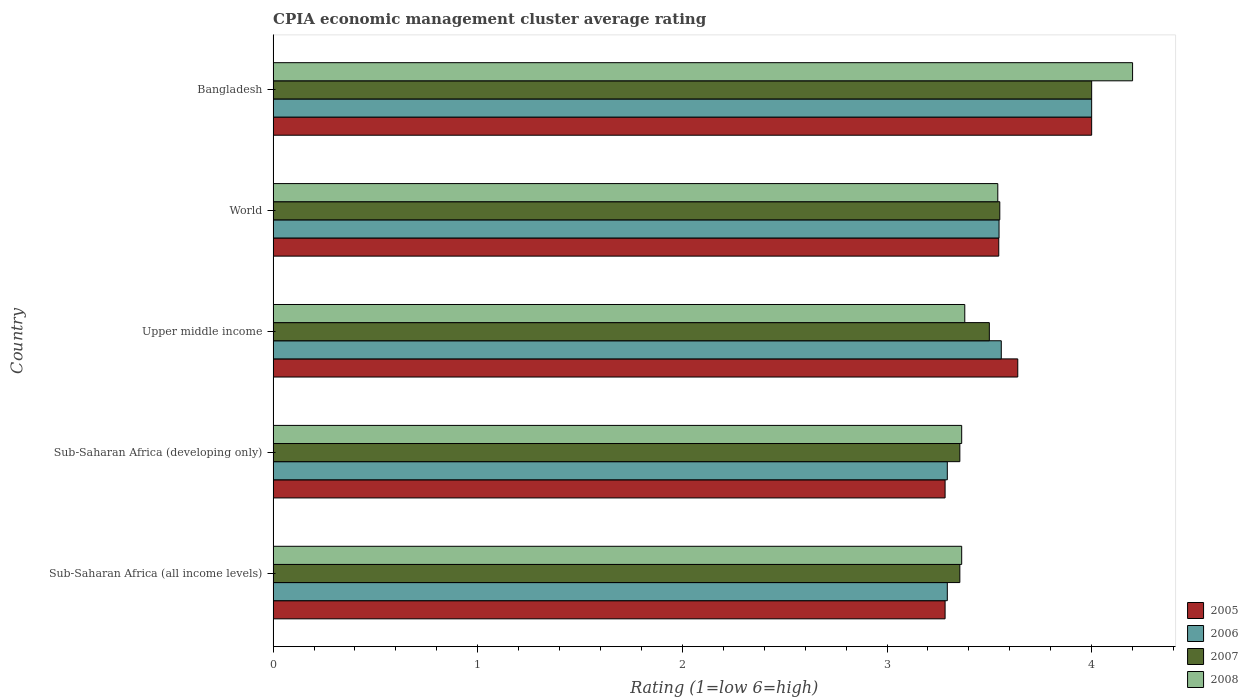How many different coloured bars are there?
Make the answer very short. 4. How many groups of bars are there?
Ensure brevity in your answer.  5. Are the number of bars per tick equal to the number of legend labels?
Your answer should be compact. Yes. Are the number of bars on each tick of the Y-axis equal?
Give a very brief answer. Yes. How many bars are there on the 5th tick from the bottom?
Give a very brief answer. 4. What is the label of the 3rd group of bars from the top?
Ensure brevity in your answer.  Upper middle income. What is the CPIA rating in 2008 in Sub-Saharan Africa (developing only)?
Make the answer very short. 3.36. Across all countries, what is the maximum CPIA rating in 2005?
Provide a short and direct response. 4. Across all countries, what is the minimum CPIA rating in 2008?
Offer a terse response. 3.36. In which country was the CPIA rating in 2006 minimum?
Provide a short and direct response. Sub-Saharan Africa (all income levels). What is the total CPIA rating in 2006 in the graph?
Give a very brief answer. 17.69. What is the difference between the CPIA rating in 2008 in Bangladesh and that in Sub-Saharan Africa (developing only)?
Make the answer very short. 0.84. What is the difference between the CPIA rating in 2008 in Sub-Saharan Africa (all income levels) and the CPIA rating in 2005 in World?
Ensure brevity in your answer.  -0.18. What is the average CPIA rating in 2007 per country?
Your answer should be very brief. 3.55. What is the difference between the CPIA rating in 2006 and CPIA rating in 2005 in Sub-Saharan Africa (all income levels)?
Your answer should be very brief. 0.01. What is the ratio of the CPIA rating in 2005 in Bangladesh to that in World?
Your answer should be compact. 1.13. Is the CPIA rating in 2006 in Sub-Saharan Africa (all income levels) less than that in Upper middle income?
Your answer should be compact. Yes. What is the difference between the highest and the second highest CPIA rating in 2007?
Provide a succinct answer. 0.45. What is the difference between the highest and the lowest CPIA rating in 2007?
Provide a short and direct response. 0.64. In how many countries, is the CPIA rating in 2007 greater than the average CPIA rating in 2007 taken over all countries?
Make the answer very short. 1. Is the sum of the CPIA rating in 2006 in Bangladesh and Sub-Saharan Africa (all income levels) greater than the maximum CPIA rating in 2007 across all countries?
Make the answer very short. Yes. Is it the case that in every country, the sum of the CPIA rating in 2008 and CPIA rating in 2007 is greater than the sum of CPIA rating in 2006 and CPIA rating in 2005?
Offer a very short reply. No. How many bars are there?
Ensure brevity in your answer.  20. What is the difference between two consecutive major ticks on the X-axis?
Ensure brevity in your answer.  1. Does the graph contain any zero values?
Give a very brief answer. No. Does the graph contain grids?
Your answer should be very brief. No. Where does the legend appear in the graph?
Keep it short and to the point. Bottom right. What is the title of the graph?
Offer a very short reply. CPIA economic management cluster average rating. What is the label or title of the X-axis?
Your answer should be very brief. Rating (1=low 6=high). What is the label or title of the Y-axis?
Keep it short and to the point. Country. What is the Rating (1=low 6=high) in 2005 in Sub-Saharan Africa (all income levels)?
Your response must be concise. 3.28. What is the Rating (1=low 6=high) of 2006 in Sub-Saharan Africa (all income levels)?
Make the answer very short. 3.29. What is the Rating (1=low 6=high) of 2007 in Sub-Saharan Africa (all income levels)?
Your answer should be compact. 3.36. What is the Rating (1=low 6=high) in 2008 in Sub-Saharan Africa (all income levels)?
Offer a very short reply. 3.36. What is the Rating (1=low 6=high) in 2005 in Sub-Saharan Africa (developing only)?
Your answer should be compact. 3.28. What is the Rating (1=low 6=high) in 2006 in Sub-Saharan Africa (developing only)?
Keep it short and to the point. 3.29. What is the Rating (1=low 6=high) in 2007 in Sub-Saharan Africa (developing only)?
Your answer should be very brief. 3.36. What is the Rating (1=low 6=high) of 2008 in Sub-Saharan Africa (developing only)?
Provide a short and direct response. 3.36. What is the Rating (1=low 6=high) of 2005 in Upper middle income?
Offer a very short reply. 3.64. What is the Rating (1=low 6=high) of 2006 in Upper middle income?
Provide a succinct answer. 3.56. What is the Rating (1=low 6=high) of 2008 in Upper middle income?
Offer a terse response. 3.38. What is the Rating (1=low 6=high) of 2005 in World?
Give a very brief answer. 3.55. What is the Rating (1=low 6=high) of 2006 in World?
Offer a very short reply. 3.55. What is the Rating (1=low 6=high) of 2007 in World?
Your response must be concise. 3.55. What is the Rating (1=low 6=high) of 2008 in World?
Keep it short and to the point. 3.54. What is the Rating (1=low 6=high) of 2005 in Bangladesh?
Your response must be concise. 4. What is the Rating (1=low 6=high) in 2007 in Bangladesh?
Offer a terse response. 4. What is the Rating (1=low 6=high) of 2008 in Bangladesh?
Provide a succinct answer. 4.2. Across all countries, what is the maximum Rating (1=low 6=high) of 2006?
Offer a terse response. 4. Across all countries, what is the maximum Rating (1=low 6=high) in 2008?
Ensure brevity in your answer.  4.2. Across all countries, what is the minimum Rating (1=low 6=high) of 2005?
Give a very brief answer. 3.28. Across all countries, what is the minimum Rating (1=low 6=high) in 2006?
Your response must be concise. 3.29. Across all countries, what is the minimum Rating (1=low 6=high) in 2007?
Make the answer very short. 3.36. Across all countries, what is the minimum Rating (1=low 6=high) of 2008?
Your answer should be very brief. 3.36. What is the total Rating (1=low 6=high) of 2005 in the graph?
Keep it short and to the point. 17.75. What is the total Rating (1=low 6=high) in 2006 in the graph?
Ensure brevity in your answer.  17.7. What is the total Rating (1=low 6=high) in 2007 in the graph?
Provide a succinct answer. 17.76. What is the total Rating (1=low 6=high) of 2008 in the graph?
Ensure brevity in your answer.  17.85. What is the difference between the Rating (1=low 6=high) in 2006 in Sub-Saharan Africa (all income levels) and that in Sub-Saharan Africa (developing only)?
Offer a terse response. 0. What is the difference between the Rating (1=low 6=high) of 2005 in Sub-Saharan Africa (all income levels) and that in Upper middle income?
Offer a terse response. -0.36. What is the difference between the Rating (1=low 6=high) in 2006 in Sub-Saharan Africa (all income levels) and that in Upper middle income?
Offer a terse response. -0.26. What is the difference between the Rating (1=low 6=high) in 2007 in Sub-Saharan Africa (all income levels) and that in Upper middle income?
Make the answer very short. -0.14. What is the difference between the Rating (1=low 6=high) in 2008 in Sub-Saharan Africa (all income levels) and that in Upper middle income?
Offer a terse response. -0.02. What is the difference between the Rating (1=low 6=high) of 2005 in Sub-Saharan Africa (all income levels) and that in World?
Offer a very short reply. -0.26. What is the difference between the Rating (1=low 6=high) of 2006 in Sub-Saharan Africa (all income levels) and that in World?
Your answer should be compact. -0.25. What is the difference between the Rating (1=low 6=high) in 2007 in Sub-Saharan Africa (all income levels) and that in World?
Your answer should be compact. -0.2. What is the difference between the Rating (1=low 6=high) of 2008 in Sub-Saharan Africa (all income levels) and that in World?
Your answer should be compact. -0.18. What is the difference between the Rating (1=low 6=high) of 2005 in Sub-Saharan Africa (all income levels) and that in Bangladesh?
Your answer should be compact. -0.72. What is the difference between the Rating (1=low 6=high) of 2006 in Sub-Saharan Africa (all income levels) and that in Bangladesh?
Keep it short and to the point. -0.71. What is the difference between the Rating (1=low 6=high) in 2007 in Sub-Saharan Africa (all income levels) and that in Bangladesh?
Ensure brevity in your answer.  -0.64. What is the difference between the Rating (1=low 6=high) of 2008 in Sub-Saharan Africa (all income levels) and that in Bangladesh?
Your answer should be compact. -0.84. What is the difference between the Rating (1=low 6=high) in 2005 in Sub-Saharan Africa (developing only) and that in Upper middle income?
Ensure brevity in your answer.  -0.36. What is the difference between the Rating (1=low 6=high) of 2006 in Sub-Saharan Africa (developing only) and that in Upper middle income?
Provide a short and direct response. -0.26. What is the difference between the Rating (1=low 6=high) of 2007 in Sub-Saharan Africa (developing only) and that in Upper middle income?
Give a very brief answer. -0.14. What is the difference between the Rating (1=low 6=high) in 2008 in Sub-Saharan Africa (developing only) and that in Upper middle income?
Ensure brevity in your answer.  -0.02. What is the difference between the Rating (1=low 6=high) in 2005 in Sub-Saharan Africa (developing only) and that in World?
Keep it short and to the point. -0.26. What is the difference between the Rating (1=low 6=high) of 2006 in Sub-Saharan Africa (developing only) and that in World?
Ensure brevity in your answer.  -0.25. What is the difference between the Rating (1=low 6=high) in 2007 in Sub-Saharan Africa (developing only) and that in World?
Your answer should be very brief. -0.2. What is the difference between the Rating (1=low 6=high) in 2008 in Sub-Saharan Africa (developing only) and that in World?
Offer a terse response. -0.18. What is the difference between the Rating (1=low 6=high) of 2005 in Sub-Saharan Africa (developing only) and that in Bangladesh?
Give a very brief answer. -0.72. What is the difference between the Rating (1=low 6=high) in 2006 in Sub-Saharan Africa (developing only) and that in Bangladesh?
Your answer should be very brief. -0.71. What is the difference between the Rating (1=low 6=high) in 2007 in Sub-Saharan Africa (developing only) and that in Bangladesh?
Ensure brevity in your answer.  -0.64. What is the difference between the Rating (1=low 6=high) of 2008 in Sub-Saharan Africa (developing only) and that in Bangladesh?
Give a very brief answer. -0.84. What is the difference between the Rating (1=low 6=high) of 2005 in Upper middle income and that in World?
Provide a succinct answer. 0.09. What is the difference between the Rating (1=low 6=high) of 2006 in Upper middle income and that in World?
Provide a succinct answer. 0.01. What is the difference between the Rating (1=low 6=high) in 2007 in Upper middle income and that in World?
Provide a succinct answer. -0.05. What is the difference between the Rating (1=low 6=high) in 2008 in Upper middle income and that in World?
Your response must be concise. -0.16. What is the difference between the Rating (1=low 6=high) of 2005 in Upper middle income and that in Bangladesh?
Provide a short and direct response. -0.36. What is the difference between the Rating (1=low 6=high) in 2006 in Upper middle income and that in Bangladesh?
Provide a short and direct response. -0.44. What is the difference between the Rating (1=low 6=high) of 2007 in Upper middle income and that in Bangladesh?
Offer a terse response. -0.5. What is the difference between the Rating (1=low 6=high) in 2008 in Upper middle income and that in Bangladesh?
Keep it short and to the point. -0.82. What is the difference between the Rating (1=low 6=high) of 2005 in World and that in Bangladesh?
Your response must be concise. -0.45. What is the difference between the Rating (1=low 6=high) in 2006 in World and that in Bangladesh?
Your response must be concise. -0.45. What is the difference between the Rating (1=low 6=high) of 2007 in World and that in Bangladesh?
Provide a short and direct response. -0.45. What is the difference between the Rating (1=low 6=high) in 2008 in World and that in Bangladesh?
Make the answer very short. -0.66. What is the difference between the Rating (1=low 6=high) in 2005 in Sub-Saharan Africa (all income levels) and the Rating (1=low 6=high) in 2006 in Sub-Saharan Africa (developing only)?
Give a very brief answer. -0.01. What is the difference between the Rating (1=low 6=high) of 2005 in Sub-Saharan Africa (all income levels) and the Rating (1=low 6=high) of 2007 in Sub-Saharan Africa (developing only)?
Provide a short and direct response. -0.07. What is the difference between the Rating (1=low 6=high) in 2005 in Sub-Saharan Africa (all income levels) and the Rating (1=low 6=high) in 2008 in Sub-Saharan Africa (developing only)?
Your response must be concise. -0.08. What is the difference between the Rating (1=low 6=high) of 2006 in Sub-Saharan Africa (all income levels) and the Rating (1=low 6=high) of 2007 in Sub-Saharan Africa (developing only)?
Make the answer very short. -0.06. What is the difference between the Rating (1=low 6=high) of 2006 in Sub-Saharan Africa (all income levels) and the Rating (1=low 6=high) of 2008 in Sub-Saharan Africa (developing only)?
Make the answer very short. -0.07. What is the difference between the Rating (1=low 6=high) of 2007 in Sub-Saharan Africa (all income levels) and the Rating (1=low 6=high) of 2008 in Sub-Saharan Africa (developing only)?
Your answer should be very brief. -0.01. What is the difference between the Rating (1=low 6=high) of 2005 in Sub-Saharan Africa (all income levels) and the Rating (1=low 6=high) of 2006 in Upper middle income?
Offer a very short reply. -0.27. What is the difference between the Rating (1=low 6=high) in 2005 in Sub-Saharan Africa (all income levels) and the Rating (1=low 6=high) in 2007 in Upper middle income?
Provide a short and direct response. -0.22. What is the difference between the Rating (1=low 6=high) of 2005 in Sub-Saharan Africa (all income levels) and the Rating (1=low 6=high) of 2008 in Upper middle income?
Offer a terse response. -0.1. What is the difference between the Rating (1=low 6=high) of 2006 in Sub-Saharan Africa (all income levels) and the Rating (1=low 6=high) of 2007 in Upper middle income?
Your answer should be compact. -0.21. What is the difference between the Rating (1=low 6=high) of 2006 in Sub-Saharan Africa (all income levels) and the Rating (1=low 6=high) of 2008 in Upper middle income?
Your response must be concise. -0.09. What is the difference between the Rating (1=low 6=high) in 2007 in Sub-Saharan Africa (all income levels) and the Rating (1=low 6=high) in 2008 in Upper middle income?
Provide a short and direct response. -0.02. What is the difference between the Rating (1=low 6=high) in 2005 in Sub-Saharan Africa (all income levels) and the Rating (1=low 6=high) in 2006 in World?
Ensure brevity in your answer.  -0.26. What is the difference between the Rating (1=low 6=high) of 2005 in Sub-Saharan Africa (all income levels) and the Rating (1=low 6=high) of 2007 in World?
Your answer should be very brief. -0.27. What is the difference between the Rating (1=low 6=high) of 2005 in Sub-Saharan Africa (all income levels) and the Rating (1=low 6=high) of 2008 in World?
Keep it short and to the point. -0.26. What is the difference between the Rating (1=low 6=high) of 2006 in Sub-Saharan Africa (all income levels) and the Rating (1=low 6=high) of 2007 in World?
Provide a short and direct response. -0.26. What is the difference between the Rating (1=low 6=high) of 2006 in Sub-Saharan Africa (all income levels) and the Rating (1=low 6=high) of 2008 in World?
Your answer should be very brief. -0.25. What is the difference between the Rating (1=low 6=high) in 2007 in Sub-Saharan Africa (all income levels) and the Rating (1=low 6=high) in 2008 in World?
Offer a very short reply. -0.19. What is the difference between the Rating (1=low 6=high) of 2005 in Sub-Saharan Africa (all income levels) and the Rating (1=low 6=high) of 2006 in Bangladesh?
Give a very brief answer. -0.72. What is the difference between the Rating (1=low 6=high) of 2005 in Sub-Saharan Africa (all income levels) and the Rating (1=low 6=high) of 2007 in Bangladesh?
Ensure brevity in your answer.  -0.72. What is the difference between the Rating (1=low 6=high) of 2005 in Sub-Saharan Africa (all income levels) and the Rating (1=low 6=high) of 2008 in Bangladesh?
Provide a short and direct response. -0.92. What is the difference between the Rating (1=low 6=high) in 2006 in Sub-Saharan Africa (all income levels) and the Rating (1=low 6=high) in 2007 in Bangladesh?
Provide a short and direct response. -0.71. What is the difference between the Rating (1=low 6=high) in 2006 in Sub-Saharan Africa (all income levels) and the Rating (1=low 6=high) in 2008 in Bangladesh?
Keep it short and to the point. -0.91. What is the difference between the Rating (1=low 6=high) of 2007 in Sub-Saharan Africa (all income levels) and the Rating (1=low 6=high) of 2008 in Bangladesh?
Your answer should be compact. -0.84. What is the difference between the Rating (1=low 6=high) of 2005 in Sub-Saharan Africa (developing only) and the Rating (1=low 6=high) of 2006 in Upper middle income?
Your answer should be compact. -0.27. What is the difference between the Rating (1=low 6=high) of 2005 in Sub-Saharan Africa (developing only) and the Rating (1=low 6=high) of 2007 in Upper middle income?
Give a very brief answer. -0.22. What is the difference between the Rating (1=low 6=high) of 2005 in Sub-Saharan Africa (developing only) and the Rating (1=low 6=high) of 2008 in Upper middle income?
Make the answer very short. -0.1. What is the difference between the Rating (1=low 6=high) in 2006 in Sub-Saharan Africa (developing only) and the Rating (1=low 6=high) in 2007 in Upper middle income?
Provide a short and direct response. -0.21. What is the difference between the Rating (1=low 6=high) in 2006 in Sub-Saharan Africa (developing only) and the Rating (1=low 6=high) in 2008 in Upper middle income?
Your answer should be compact. -0.09. What is the difference between the Rating (1=low 6=high) in 2007 in Sub-Saharan Africa (developing only) and the Rating (1=low 6=high) in 2008 in Upper middle income?
Your response must be concise. -0.02. What is the difference between the Rating (1=low 6=high) of 2005 in Sub-Saharan Africa (developing only) and the Rating (1=low 6=high) of 2006 in World?
Keep it short and to the point. -0.26. What is the difference between the Rating (1=low 6=high) of 2005 in Sub-Saharan Africa (developing only) and the Rating (1=low 6=high) of 2007 in World?
Your answer should be very brief. -0.27. What is the difference between the Rating (1=low 6=high) of 2005 in Sub-Saharan Africa (developing only) and the Rating (1=low 6=high) of 2008 in World?
Offer a terse response. -0.26. What is the difference between the Rating (1=low 6=high) of 2006 in Sub-Saharan Africa (developing only) and the Rating (1=low 6=high) of 2007 in World?
Provide a succinct answer. -0.26. What is the difference between the Rating (1=low 6=high) of 2006 in Sub-Saharan Africa (developing only) and the Rating (1=low 6=high) of 2008 in World?
Your response must be concise. -0.25. What is the difference between the Rating (1=low 6=high) of 2007 in Sub-Saharan Africa (developing only) and the Rating (1=low 6=high) of 2008 in World?
Your answer should be compact. -0.19. What is the difference between the Rating (1=low 6=high) of 2005 in Sub-Saharan Africa (developing only) and the Rating (1=low 6=high) of 2006 in Bangladesh?
Provide a short and direct response. -0.72. What is the difference between the Rating (1=low 6=high) of 2005 in Sub-Saharan Africa (developing only) and the Rating (1=low 6=high) of 2007 in Bangladesh?
Keep it short and to the point. -0.72. What is the difference between the Rating (1=low 6=high) of 2005 in Sub-Saharan Africa (developing only) and the Rating (1=low 6=high) of 2008 in Bangladesh?
Make the answer very short. -0.92. What is the difference between the Rating (1=low 6=high) of 2006 in Sub-Saharan Africa (developing only) and the Rating (1=low 6=high) of 2007 in Bangladesh?
Provide a short and direct response. -0.71. What is the difference between the Rating (1=low 6=high) in 2006 in Sub-Saharan Africa (developing only) and the Rating (1=low 6=high) in 2008 in Bangladesh?
Give a very brief answer. -0.91. What is the difference between the Rating (1=low 6=high) of 2007 in Sub-Saharan Africa (developing only) and the Rating (1=low 6=high) of 2008 in Bangladesh?
Your answer should be very brief. -0.84. What is the difference between the Rating (1=low 6=high) in 2005 in Upper middle income and the Rating (1=low 6=high) in 2006 in World?
Ensure brevity in your answer.  0.09. What is the difference between the Rating (1=low 6=high) of 2005 in Upper middle income and the Rating (1=low 6=high) of 2007 in World?
Give a very brief answer. 0.09. What is the difference between the Rating (1=low 6=high) of 2005 in Upper middle income and the Rating (1=low 6=high) of 2008 in World?
Keep it short and to the point. 0.1. What is the difference between the Rating (1=low 6=high) of 2006 in Upper middle income and the Rating (1=low 6=high) of 2007 in World?
Your answer should be compact. 0.01. What is the difference between the Rating (1=low 6=high) in 2006 in Upper middle income and the Rating (1=low 6=high) in 2008 in World?
Offer a very short reply. 0.02. What is the difference between the Rating (1=low 6=high) of 2007 in Upper middle income and the Rating (1=low 6=high) of 2008 in World?
Your answer should be compact. -0.04. What is the difference between the Rating (1=low 6=high) of 2005 in Upper middle income and the Rating (1=low 6=high) of 2006 in Bangladesh?
Make the answer very short. -0.36. What is the difference between the Rating (1=low 6=high) in 2005 in Upper middle income and the Rating (1=low 6=high) in 2007 in Bangladesh?
Your answer should be very brief. -0.36. What is the difference between the Rating (1=low 6=high) of 2005 in Upper middle income and the Rating (1=low 6=high) of 2008 in Bangladesh?
Offer a terse response. -0.56. What is the difference between the Rating (1=low 6=high) in 2006 in Upper middle income and the Rating (1=low 6=high) in 2007 in Bangladesh?
Your response must be concise. -0.44. What is the difference between the Rating (1=low 6=high) in 2006 in Upper middle income and the Rating (1=low 6=high) in 2008 in Bangladesh?
Your answer should be very brief. -0.64. What is the difference between the Rating (1=low 6=high) of 2005 in World and the Rating (1=low 6=high) of 2006 in Bangladesh?
Give a very brief answer. -0.45. What is the difference between the Rating (1=low 6=high) of 2005 in World and the Rating (1=low 6=high) of 2007 in Bangladesh?
Provide a succinct answer. -0.45. What is the difference between the Rating (1=low 6=high) of 2005 in World and the Rating (1=low 6=high) of 2008 in Bangladesh?
Keep it short and to the point. -0.65. What is the difference between the Rating (1=low 6=high) of 2006 in World and the Rating (1=low 6=high) of 2007 in Bangladesh?
Your answer should be compact. -0.45. What is the difference between the Rating (1=low 6=high) of 2006 in World and the Rating (1=low 6=high) of 2008 in Bangladesh?
Provide a succinct answer. -0.65. What is the difference between the Rating (1=low 6=high) of 2007 in World and the Rating (1=low 6=high) of 2008 in Bangladesh?
Keep it short and to the point. -0.65. What is the average Rating (1=low 6=high) of 2005 per country?
Your answer should be very brief. 3.55. What is the average Rating (1=low 6=high) of 2006 per country?
Offer a terse response. 3.54. What is the average Rating (1=low 6=high) in 2007 per country?
Offer a terse response. 3.55. What is the average Rating (1=low 6=high) of 2008 per country?
Your answer should be compact. 3.57. What is the difference between the Rating (1=low 6=high) of 2005 and Rating (1=low 6=high) of 2006 in Sub-Saharan Africa (all income levels)?
Offer a very short reply. -0.01. What is the difference between the Rating (1=low 6=high) in 2005 and Rating (1=low 6=high) in 2007 in Sub-Saharan Africa (all income levels)?
Make the answer very short. -0.07. What is the difference between the Rating (1=low 6=high) of 2005 and Rating (1=low 6=high) of 2008 in Sub-Saharan Africa (all income levels)?
Keep it short and to the point. -0.08. What is the difference between the Rating (1=low 6=high) of 2006 and Rating (1=low 6=high) of 2007 in Sub-Saharan Africa (all income levels)?
Provide a short and direct response. -0.06. What is the difference between the Rating (1=low 6=high) of 2006 and Rating (1=low 6=high) of 2008 in Sub-Saharan Africa (all income levels)?
Your answer should be compact. -0.07. What is the difference between the Rating (1=low 6=high) in 2007 and Rating (1=low 6=high) in 2008 in Sub-Saharan Africa (all income levels)?
Your response must be concise. -0.01. What is the difference between the Rating (1=low 6=high) of 2005 and Rating (1=low 6=high) of 2006 in Sub-Saharan Africa (developing only)?
Offer a terse response. -0.01. What is the difference between the Rating (1=low 6=high) in 2005 and Rating (1=low 6=high) in 2007 in Sub-Saharan Africa (developing only)?
Your response must be concise. -0.07. What is the difference between the Rating (1=low 6=high) of 2005 and Rating (1=low 6=high) of 2008 in Sub-Saharan Africa (developing only)?
Give a very brief answer. -0.08. What is the difference between the Rating (1=low 6=high) in 2006 and Rating (1=low 6=high) in 2007 in Sub-Saharan Africa (developing only)?
Your answer should be very brief. -0.06. What is the difference between the Rating (1=low 6=high) of 2006 and Rating (1=low 6=high) of 2008 in Sub-Saharan Africa (developing only)?
Offer a terse response. -0.07. What is the difference between the Rating (1=low 6=high) in 2007 and Rating (1=low 6=high) in 2008 in Sub-Saharan Africa (developing only)?
Provide a short and direct response. -0.01. What is the difference between the Rating (1=low 6=high) in 2005 and Rating (1=low 6=high) in 2006 in Upper middle income?
Offer a terse response. 0.08. What is the difference between the Rating (1=low 6=high) of 2005 and Rating (1=low 6=high) of 2007 in Upper middle income?
Your answer should be compact. 0.14. What is the difference between the Rating (1=low 6=high) in 2005 and Rating (1=low 6=high) in 2008 in Upper middle income?
Your answer should be compact. 0.26. What is the difference between the Rating (1=low 6=high) of 2006 and Rating (1=low 6=high) of 2007 in Upper middle income?
Keep it short and to the point. 0.06. What is the difference between the Rating (1=low 6=high) in 2006 and Rating (1=low 6=high) in 2008 in Upper middle income?
Your response must be concise. 0.18. What is the difference between the Rating (1=low 6=high) of 2007 and Rating (1=low 6=high) of 2008 in Upper middle income?
Provide a succinct answer. 0.12. What is the difference between the Rating (1=low 6=high) of 2005 and Rating (1=low 6=high) of 2006 in World?
Give a very brief answer. -0. What is the difference between the Rating (1=low 6=high) in 2005 and Rating (1=low 6=high) in 2007 in World?
Ensure brevity in your answer.  -0.01. What is the difference between the Rating (1=low 6=high) of 2005 and Rating (1=low 6=high) of 2008 in World?
Give a very brief answer. 0. What is the difference between the Rating (1=low 6=high) of 2006 and Rating (1=low 6=high) of 2007 in World?
Provide a short and direct response. -0. What is the difference between the Rating (1=low 6=high) of 2006 and Rating (1=low 6=high) of 2008 in World?
Make the answer very short. 0.01. What is the difference between the Rating (1=low 6=high) of 2007 and Rating (1=low 6=high) of 2008 in World?
Offer a very short reply. 0.01. What is the difference between the Rating (1=low 6=high) in 2005 and Rating (1=low 6=high) in 2006 in Bangladesh?
Provide a short and direct response. 0. What is the difference between the Rating (1=low 6=high) in 2005 and Rating (1=low 6=high) in 2007 in Bangladesh?
Ensure brevity in your answer.  0. What is the difference between the Rating (1=low 6=high) in 2006 and Rating (1=low 6=high) in 2008 in Bangladesh?
Keep it short and to the point. -0.2. What is the difference between the Rating (1=low 6=high) of 2007 and Rating (1=low 6=high) of 2008 in Bangladesh?
Make the answer very short. -0.2. What is the ratio of the Rating (1=low 6=high) of 2007 in Sub-Saharan Africa (all income levels) to that in Sub-Saharan Africa (developing only)?
Give a very brief answer. 1. What is the ratio of the Rating (1=low 6=high) in 2008 in Sub-Saharan Africa (all income levels) to that in Sub-Saharan Africa (developing only)?
Give a very brief answer. 1. What is the ratio of the Rating (1=low 6=high) in 2005 in Sub-Saharan Africa (all income levels) to that in Upper middle income?
Keep it short and to the point. 0.9. What is the ratio of the Rating (1=low 6=high) of 2006 in Sub-Saharan Africa (all income levels) to that in Upper middle income?
Provide a succinct answer. 0.93. What is the ratio of the Rating (1=low 6=high) of 2007 in Sub-Saharan Africa (all income levels) to that in Upper middle income?
Give a very brief answer. 0.96. What is the ratio of the Rating (1=low 6=high) of 2008 in Sub-Saharan Africa (all income levels) to that in Upper middle income?
Give a very brief answer. 1. What is the ratio of the Rating (1=low 6=high) of 2005 in Sub-Saharan Africa (all income levels) to that in World?
Ensure brevity in your answer.  0.93. What is the ratio of the Rating (1=low 6=high) of 2006 in Sub-Saharan Africa (all income levels) to that in World?
Your answer should be compact. 0.93. What is the ratio of the Rating (1=low 6=high) in 2007 in Sub-Saharan Africa (all income levels) to that in World?
Your response must be concise. 0.94. What is the ratio of the Rating (1=low 6=high) of 2008 in Sub-Saharan Africa (all income levels) to that in World?
Make the answer very short. 0.95. What is the ratio of the Rating (1=low 6=high) of 2005 in Sub-Saharan Africa (all income levels) to that in Bangladesh?
Offer a terse response. 0.82. What is the ratio of the Rating (1=low 6=high) in 2006 in Sub-Saharan Africa (all income levels) to that in Bangladesh?
Keep it short and to the point. 0.82. What is the ratio of the Rating (1=low 6=high) in 2007 in Sub-Saharan Africa (all income levels) to that in Bangladesh?
Your answer should be compact. 0.84. What is the ratio of the Rating (1=low 6=high) of 2008 in Sub-Saharan Africa (all income levels) to that in Bangladesh?
Ensure brevity in your answer.  0.8. What is the ratio of the Rating (1=low 6=high) of 2005 in Sub-Saharan Africa (developing only) to that in Upper middle income?
Make the answer very short. 0.9. What is the ratio of the Rating (1=low 6=high) of 2006 in Sub-Saharan Africa (developing only) to that in Upper middle income?
Make the answer very short. 0.93. What is the ratio of the Rating (1=low 6=high) in 2007 in Sub-Saharan Africa (developing only) to that in Upper middle income?
Your answer should be compact. 0.96. What is the ratio of the Rating (1=low 6=high) of 2005 in Sub-Saharan Africa (developing only) to that in World?
Ensure brevity in your answer.  0.93. What is the ratio of the Rating (1=low 6=high) in 2006 in Sub-Saharan Africa (developing only) to that in World?
Your answer should be compact. 0.93. What is the ratio of the Rating (1=low 6=high) in 2007 in Sub-Saharan Africa (developing only) to that in World?
Your response must be concise. 0.94. What is the ratio of the Rating (1=low 6=high) in 2008 in Sub-Saharan Africa (developing only) to that in World?
Ensure brevity in your answer.  0.95. What is the ratio of the Rating (1=low 6=high) in 2005 in Sub-Saharan Africa (developing only) to that in Bangladesh?
Offer a terse response. 0.82. What is the ratio of the Rating (1=low 6=high) in 2006 in Sub-Saharan Africa (developing only) to that in Bangladesh?
Provide a short and direct response. 0.82. What is the ratio of the Rating (1=low 6=high) of 2007 in Sub-Saharan Africa (developing only) to that in Bangladesh?
Offer a very short reply. 0.84. What is the ratio of the Rating (1=low 6=high) of 2008 in Sub-Saharan Africa (developing only) to that in Bangladesh?
Provide a succinct answer. 0.8. What is the ratio of the Rating (1=low 6=high) of 2005 in Upper middle income to that in World?
Give a very brief answer. 1.03. What is the ratio of the Rating (1=low 6=high) of 2007 in Upper middle income to that in World?
Your response must be concise. 0.99. What is the ratio of the Rating (1=low 6=high) of 2008 in Upper middle income to that in World?
Offer a very short reply. 0.95. What is the ratio of the Rating (1=low 6=high) of 2005 in Upper middle income to that in Bangladesh?
Give a very brief answer. 0.91. What is the ratio of the Rating (1=low 6=high) in 2006 in Upper middle income to that in Bangladesh?
Provide a short and direct response. 0.89. What is the ratio of the Rating (1=low 6=high) of 2007 in Upper middle income to that in Bangladesh?
Ensure brevity in your answer.  0.88. What is the ratio of the Rating (1=low 6=high) in 2008 in Upper middle income to that in Bangladesh?
Provide a short and direct response. 0.8. What is the ratio of the Rating (1=low 6=high) of 2005 in World to that in Bangladesh?
Provide a succinct answer. 0.89. What is the ratio of the Rating (1=low 6=high) in 2006 in World to that in Bangladesh?
Keep it short and to the point. 0.89. What is the ratio of the Rating (1=low 6=high) of 2007 in World to that in Bangladesh?
Provide a short and direct response. 0.89. What is the ratio of the Rating (1=low 6=high) in 2008 in World to that in Bangladesh?
Your answer should be compact. 0.84. What is the difference between the highest and the second highest Rating (1=low 6=high) in 2005?
Ensure brevity in your answer.  0.36. What is the difference between the highest and the second highest Rating (1=low 6=high) in 2006?
Provide a short and direct response. 0.44. What is the difference between the highest and the second highest Rating (1=low 6=high) of 2007?
Provide a short and direct response. 0.45. What is the difference between the highest and the second highest Rating (1=low 6=high) of 2008?
Offer a terse response. 0.66. What is the difference between the highest and the lowest Rating (1=low 6=high) of 2005?
Provide a succinct answer. 0.72. What is the difference between the highest and the lowest Rating (1=low 6=high) of 2006?
Offer a very short reply. 0.71. What is the difference between the highest and the lowest Rating (1=low 6=high) in 2007?
Your answer should be very brief. 0.64. What is the difference between the highest and the lowest Rating (1=low 6=high) in 2008?
Offer a terse response. 0.84. 